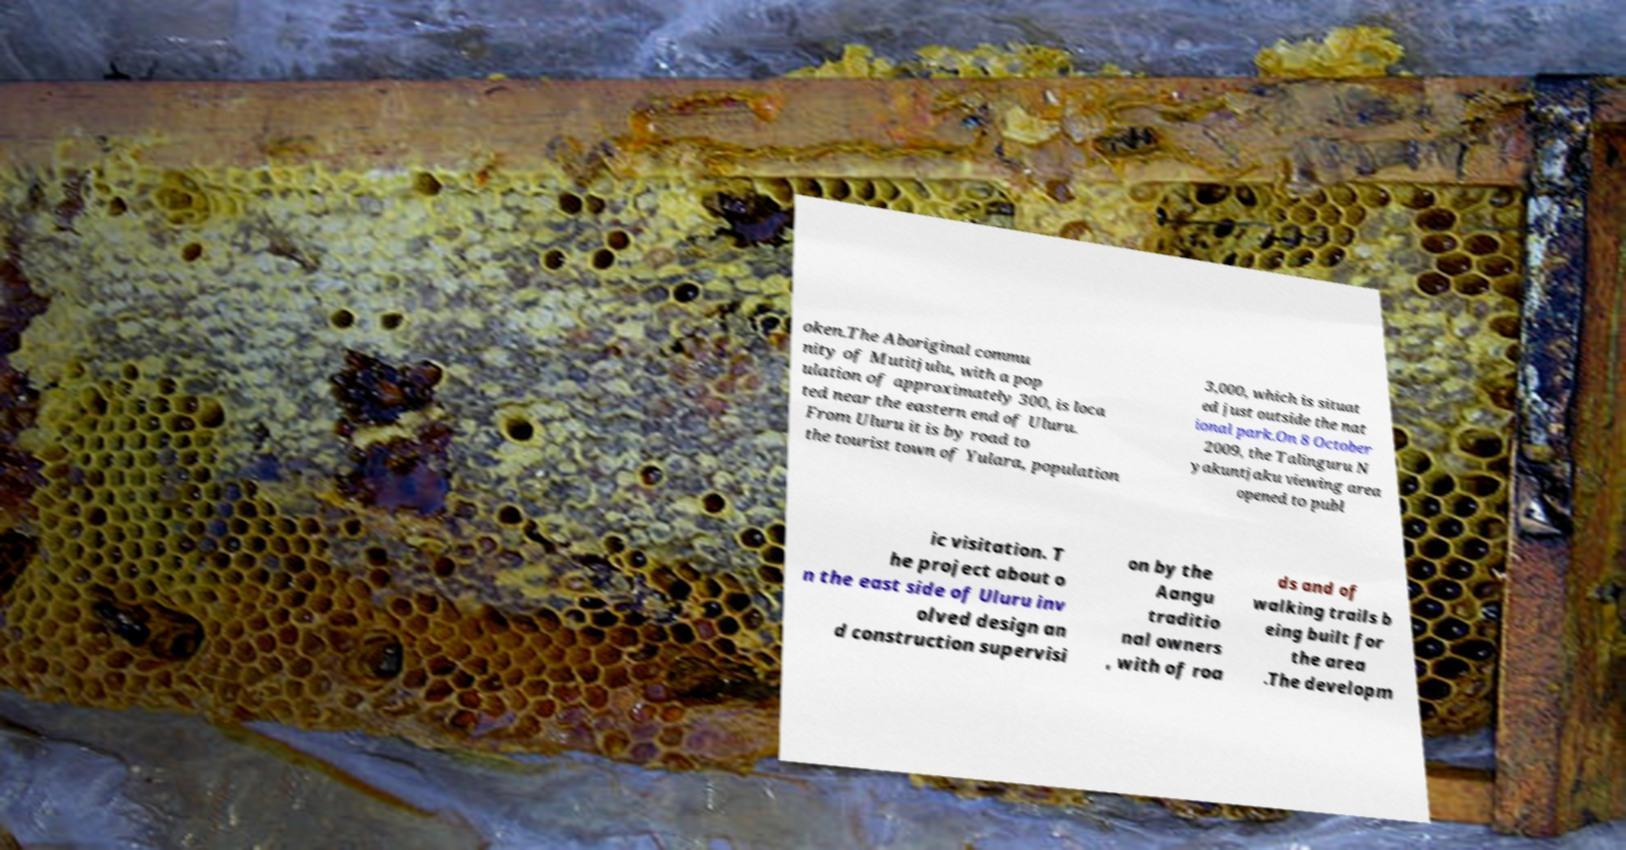I need the written content from this picture converted into text. Can you do that? oken.The Aboriginal commu nity of Mutitjulu, with a pop ulation of approximately 300, is loca ted near the eastern end of Uluru. From Uluru it is by road to the tourist town of Yulara, population 3,000, which is situat ed just outside the nat ional park.On 8 October 2009, the Talinguru N yakuntjaku viewing area opened to publ ic visitation. T he project about o n the east side of Uluru inv olved design an d construction supervisi on by the Aangu traditio nal owners , with of roa ds and of walking trails b eing built for the area .The developm 